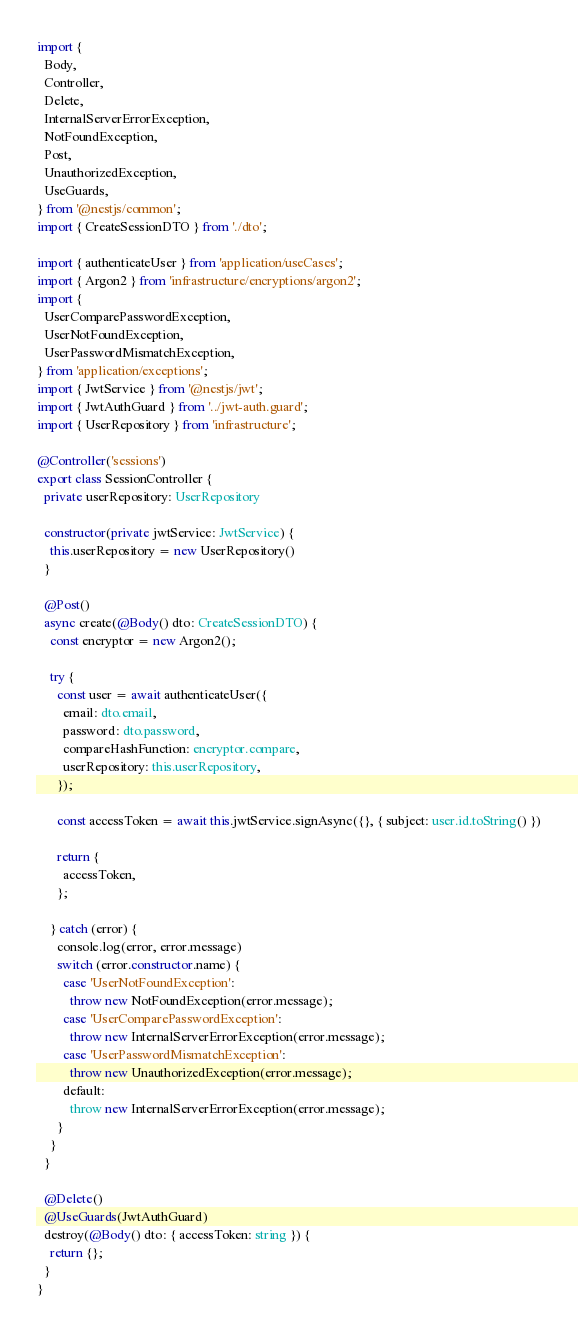<code> <loc_0><loc_0><loc_500><loc_500><_TypeScript_>import {
  Body,
  Controller,
  Delete,
  InternalServerErrorException,
  NotFoundException,
  Post,
  UnauthorizedException,
  UseGuards,
} from '@nestjs/common';
import { CreateSessionDTO } from './dto';

import { authenticateUser } from 'application/useCases';
import { Argon2 } from 'infrastructure/encryptions/argon2';
import {
  UserComparePasswordException,
  UserNotFoundException,
  UserPasswordMismatchException,
} from 'application/exceptions';
import { JwtService } from '@nestjs/jwt';
import { JwtAuthGuard } from '../jwt-auth.guard';
import { UserRepository } from 'infrastructure';

@Controller('sessions')
export class SessionController {
  private userRepository: UserRepository

  constructor(private jwtService: JwtService) {
    this.userRepository = new UserRepository()
  }

  @Post()
  async create(@Body() dto: CreateSessionDTO) {
    const encryptor = new Argon2();
  
    try {
      const user = await authenticateUser({
        email: dto.email,
        password: dto.password,
        compareHashFunction: encryptor.compare,
        userRepository: this.userRepository,
      });

      const accessToken = await this.jwtService.signAsync({}, { subject: user.id.toString() })

      return {
        accessToken,
      };

    } catch (error) {
      console.log(error, error.message)
      switch (error.constructor.name) {
        case 'UserNotFoundException':
          throw new NotFoundException(error.message);
        case 'UserComparePasswordException':
          throw new InternalServerErrorException(error.message);
        case 'UserPasswordMismatchException':
          throw new UnauthorizedException(error.message);
        default:
          throw new InternalServerErrorException(error.message);
      }
    }
  }

  @Delete()
  @UseGuards(JwtAuthGuard)
  destroy(@Body() dto: { accessToken: string }) {
    return {};
  }
}
</code> 